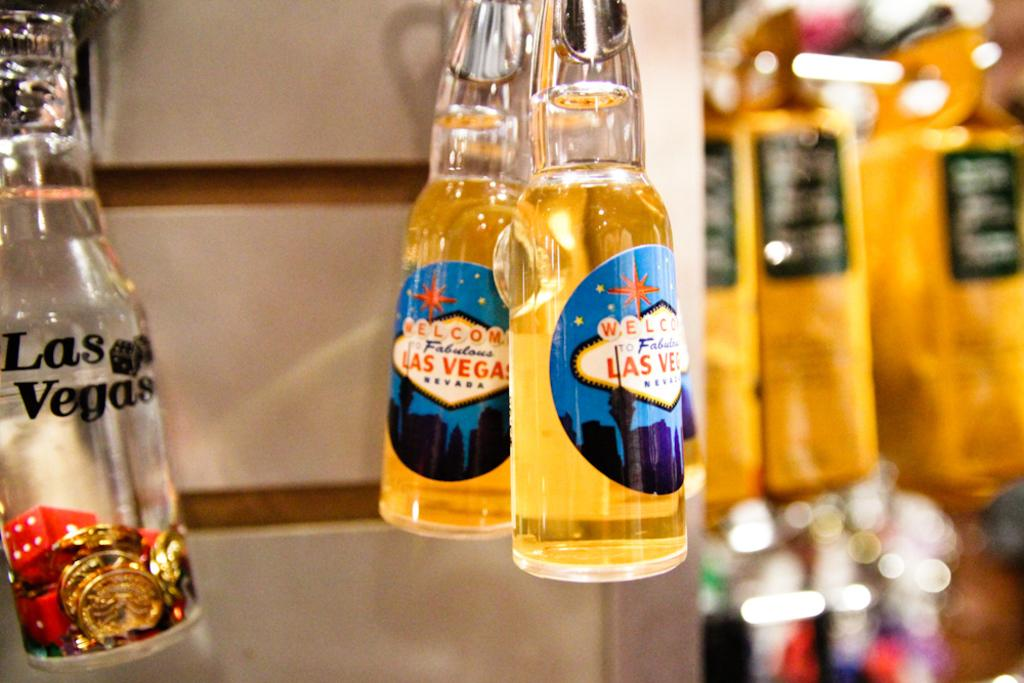How many bottles are visible in the image? There are three bottles in the image. What is written on the bottles? The bottles have "Las Vegas" written on them. What is the filling status of the bottles? Two of the bottles are fully filled, and one bottle is empty. What can be seen in the background of the image? There is a pillar in the background of the image. How many chairs are visible in the image? There are no chairs visible in the image; it only features three bottles and a pillar in the background. 